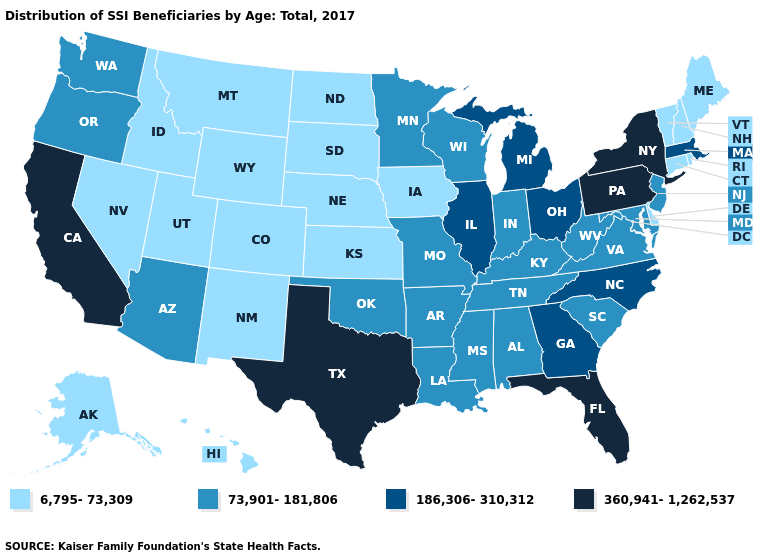What is the lowest value in states that border New York?
Keep it brief. 6,795-73,309. What is the value of Pennsylvania?
Keep it brief. 360,941-1,262,537. Name the states that have a value in the range 6,795-73,309?
Quick response, please. Alaska, Colorado, Connecticut, Delaware, Hawaii, Idaho, Iowa, Kansas, Maine, Montana, Nebraska, Nevada, New Hampshire, New Mexico, North Dakota, Rhode Island, South Dakota, Utah, Vermont, Wyoming. Name the states that have a value in the range 186,306-310,312?
Short answer required. Georgia, Illinois, Massachusetts, Michigan, North Carolina, Ohio. What is the highest value in states that border Florida?
Keep it brief. 186,306-310,312. What is the value of New York?
Write a very short answer. 360,941-1,262,537. Among the states that border Illinois , does Wisconsin have the lowest value?
Concise answer only. No. Name the states that have a value in the range 186,306-310,312?
Quick response, please. Georgia, Illinois, Massachusetts, Michigan, North Carolina, Ohio. Among the states that border Texas , does Oklahoma have the highest value?
Answer briefly. Yes. Does Massachusetts have the highest value in the USA?
Quick response, please. No. What is the value of Wyoming?
Write a very short answer. 6,795-73,309. Which states hav the highest value in the West?
Concise answer only. California. Is the legend a continuous bar?
Keep it brief. No. Among the states that border New Mexico , does Utah have the lowest value?
Keep it brief. Yes. What is the highest value in the USA?
Answer briefly. 360,941-1,262,537. 